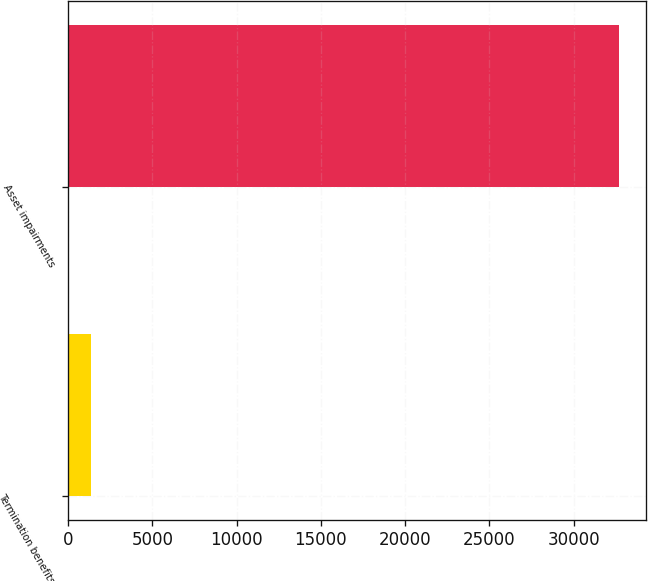<chart> <loc_0><loc_0><loc_500><loc_500><bar_chart><fcel>Termination benefits<fcel>Asset impairments<nl><fcel>1388<fcel>32662<nl></chart> 